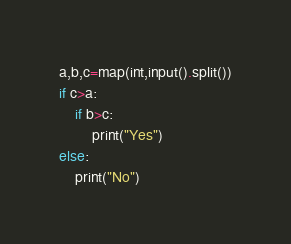Convert code to text. <code><loc_0><loc_0><loc_500><loc_500><_Python_>a,b,c=map(int,input().split())
if c>a:
    if b>c:
        print("Yes")
else:
    print("No")</code> 